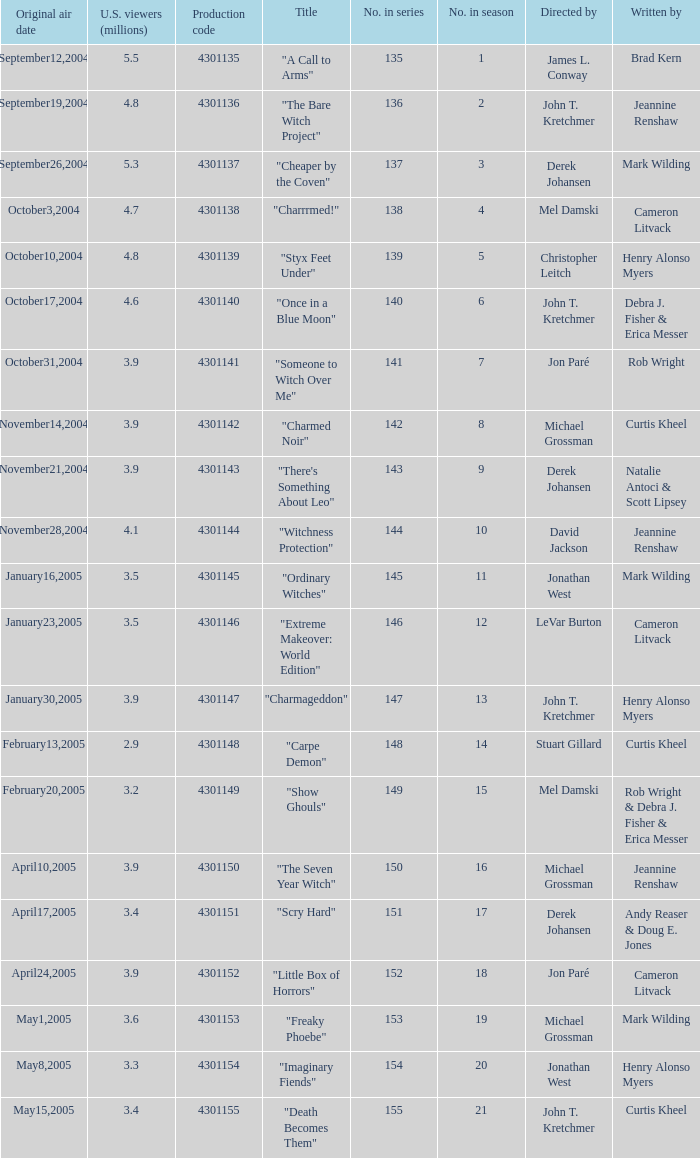When the writer is brad kern, how many u.s viewers (in millions) had the episode? 5.5. 